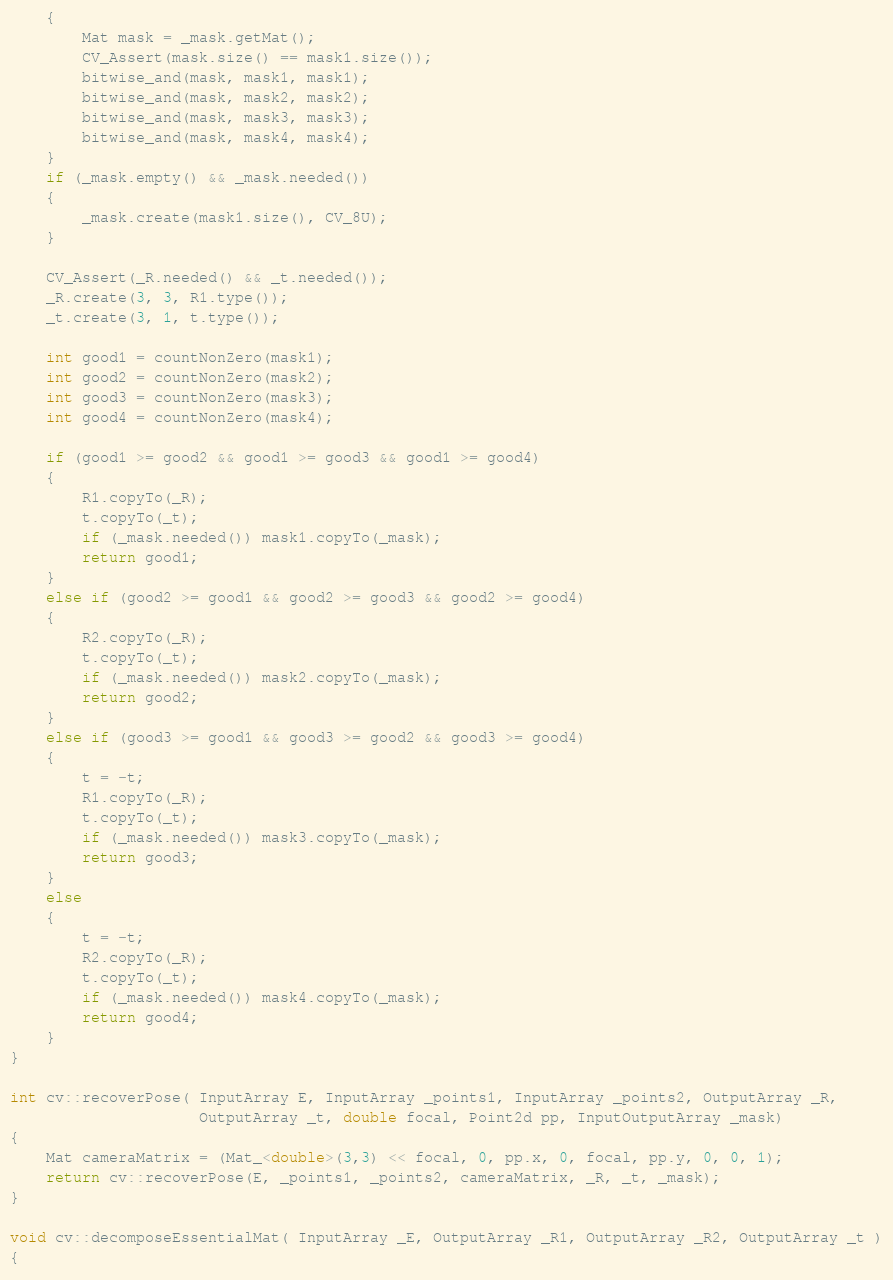<code> <loc_0><loc_0><loc_500><loc_500><_C_>    {
        Mat mask = _mask.getMat();
        CV_Assert(mask.size() == mask1.size());
        bitwise_and(mask, mask1, mask1);
        bitwise_and(mask, mask2, mask2);
        bitwise_and(mask, mask3, mask3);
        bitwise_and(mask, mask4, mask4);
    }
    if (_mask.empty() && _mask.needed())
    {
        _mask.create(mask1.size(), CV_8U);
    }

    CV_Assert(_R.needed() && _t.needed());
    _R.create(3, 3, R1.type());
    _t.create(3, 1, t.type());

    int good1 = countNonZero(mask1);
    int good2 = countNonZero(mask2);
    int good3 = countNonZero(mask3);
    int good4 = countNonZero(mask4);

    if (good1 >= good2 && good1 >= good3 && good1 >= good4)
    {
        R1.copyTo(_R);
        t.copyTo(_t);
        if (_mask.needed()) mask1.copyTo(_mask);
        return good1;
    }
    else if (good2 >= good1 && good2 >= good3 && good2 >= good4)
    {
        R2.copyTo(_R);
        t.copyTo(_t);
        if (_mask.needed()) mask2.copyTo(_mask);
        return good2;
    }
    else if (good3 >= good1 && good3 >= good2 && good3 >= good4)
    {
        t = -t;
        R1.copyTo(_R);
        t.copyTo(_t);
        if (_mask.needed()) mask3.copyTo(_mask);
        return good3;
    }
    else
    {
        t = -t;
        R2.copyTo(_R);
        t.copyTo(_t);
        if (_mask.needed()) mask4.copyTo(_mask);
        return good4;
    }
}

int cv::recoverPose( InputArray E, InputArray _points1, InputArray _points2, OutputArray _R,
                     OutputArray _t, double focal, Point2d pp, InputOutputArray _mask)
{
    Mat cameraMatrix = (Mat_<double>(3,3) << focal, 0, pp.x, 0, focal, pp.y, 0, 0, 1);
    return cv::recoverPose(E, _points1, _points2, cameraMatrix, _R, _t, _mask);
}

void cv::decomposeEssentialMat( InputArray _E, OutputArray _R1, OutputArray _R2, OutputArray _t )
{</code> 